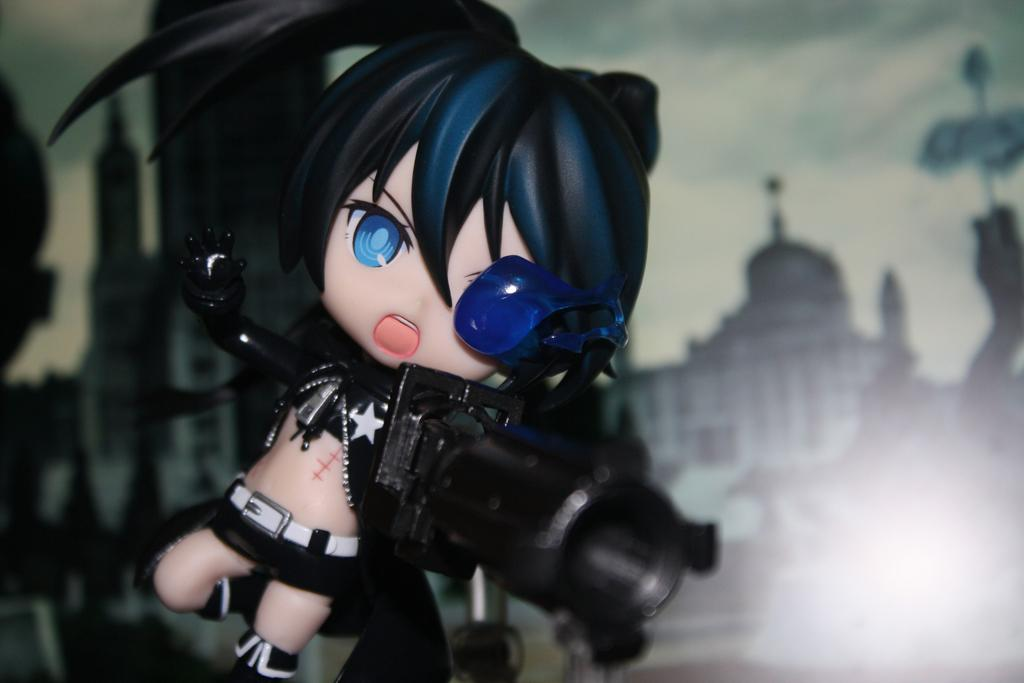What object can be seen in the picture? There is a toy in the picture. What can be seen in the distance in the picture? There is a building in the background of the picture. What part of the natural environment is visible in the picture? The sky is visible in the background of the picture. How many giants are visible in the picture? There are no giants present in the image. What type of bit is being used to eat the toy in the picture? There is no bit present in the image, and the toy is not being eaten. 